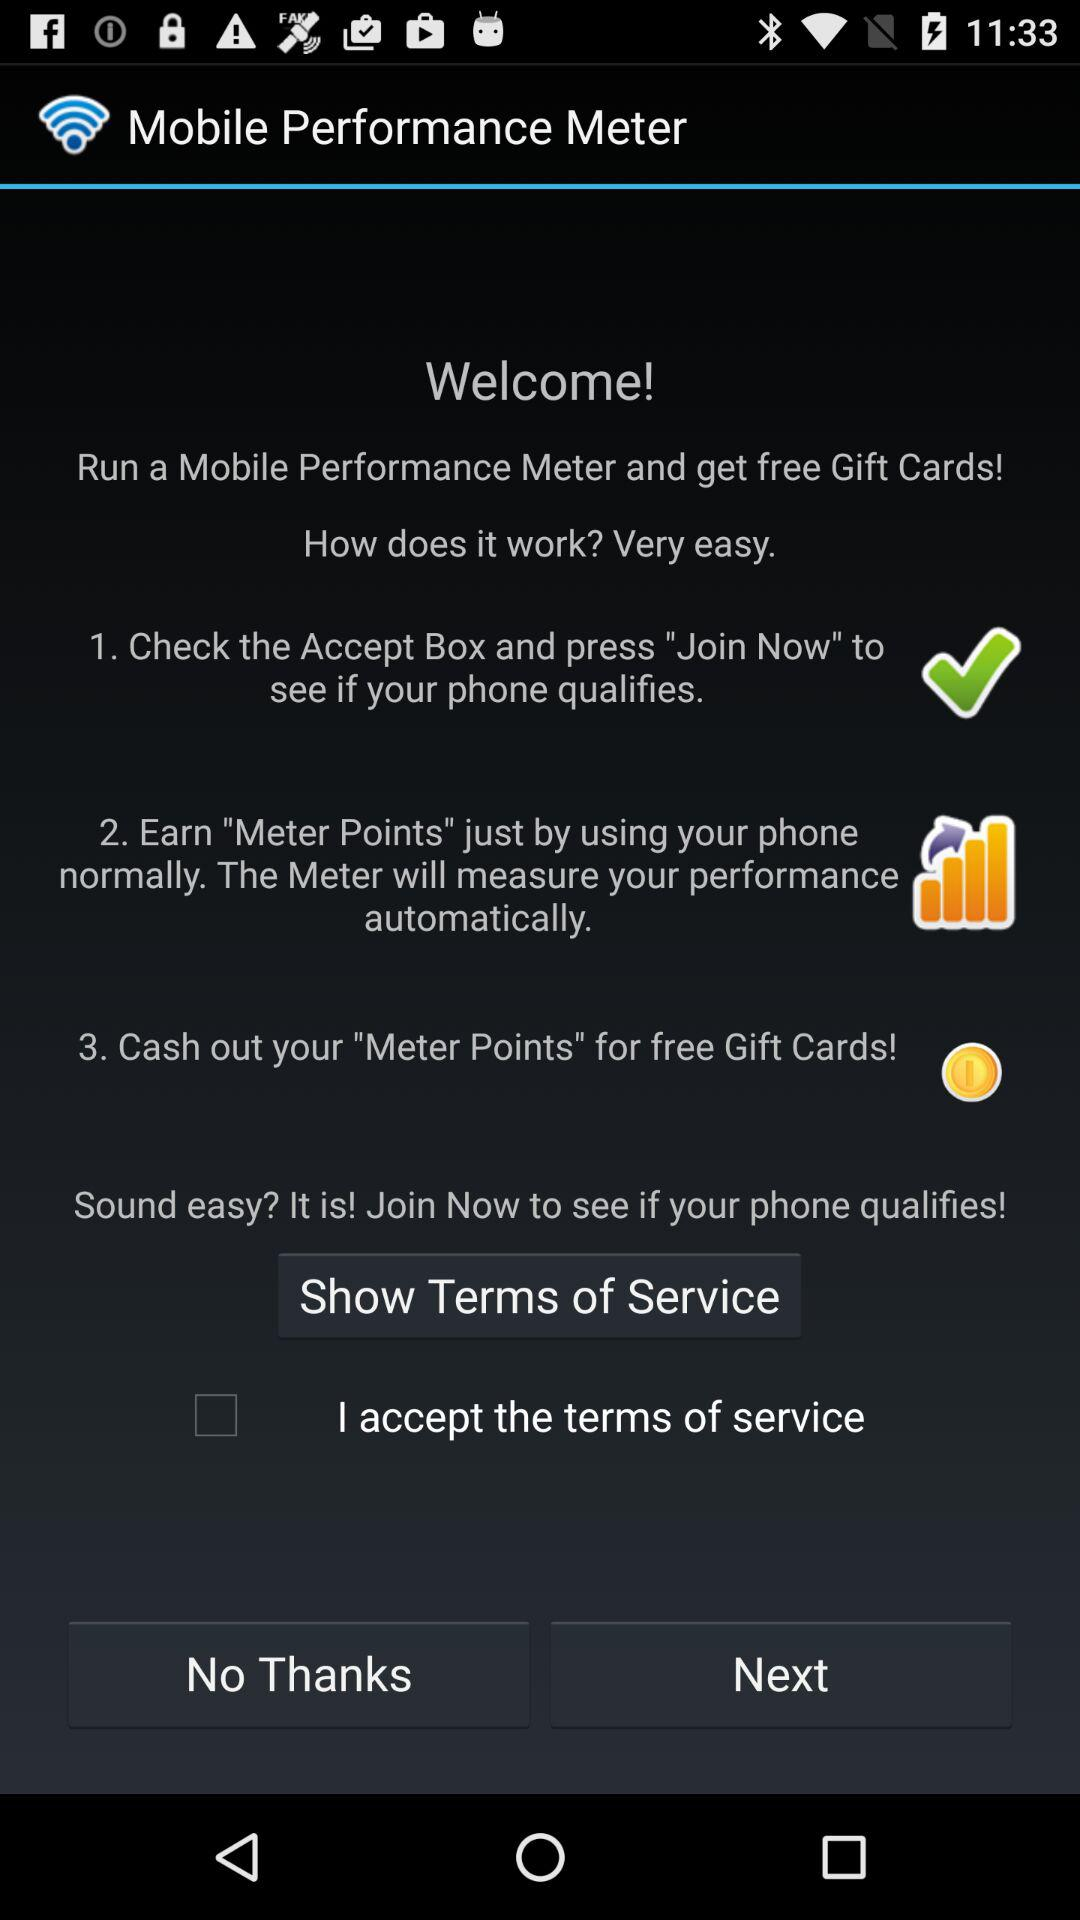What is the name of the application? The name of the application is "Mobile Performance Meter". 